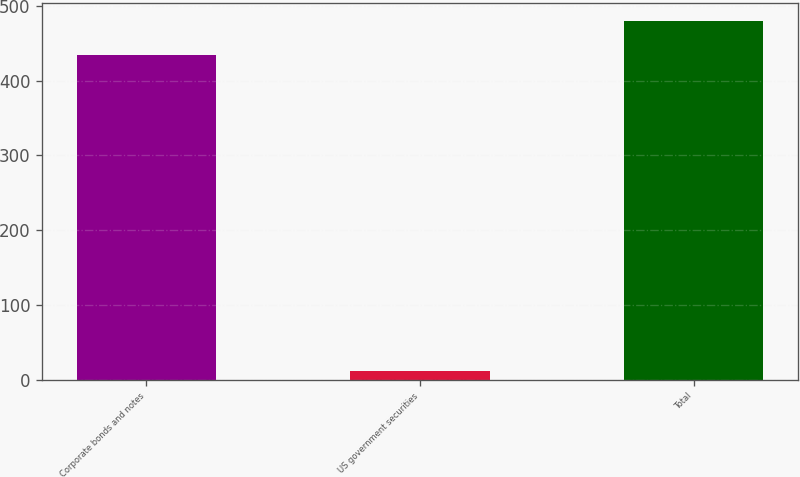<chart> <loc_0><loc_0><loc_500><loc_500><bar_chart><fcel>Corporate bonds and notes<fcel>US government securities<fcel>Total<nl><fcel>434<fcel>12<fcel>479.6<nl></chart> 